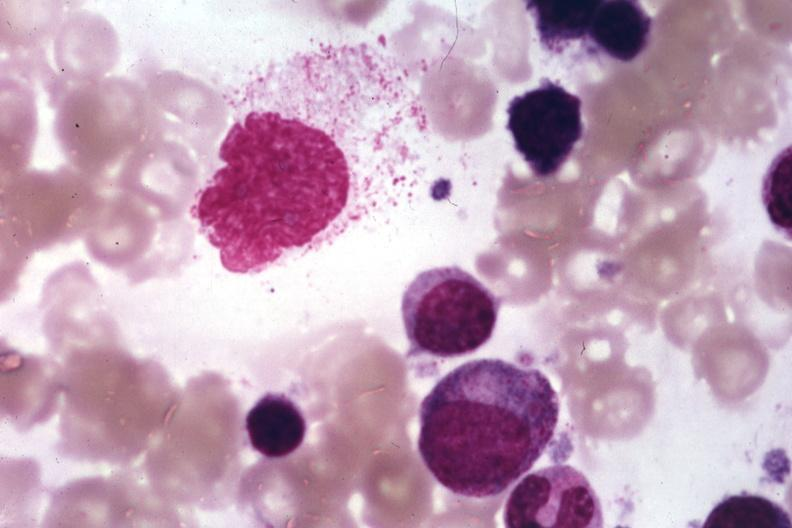what is present?
Answer the question using a single word or phrase. Hematologic 